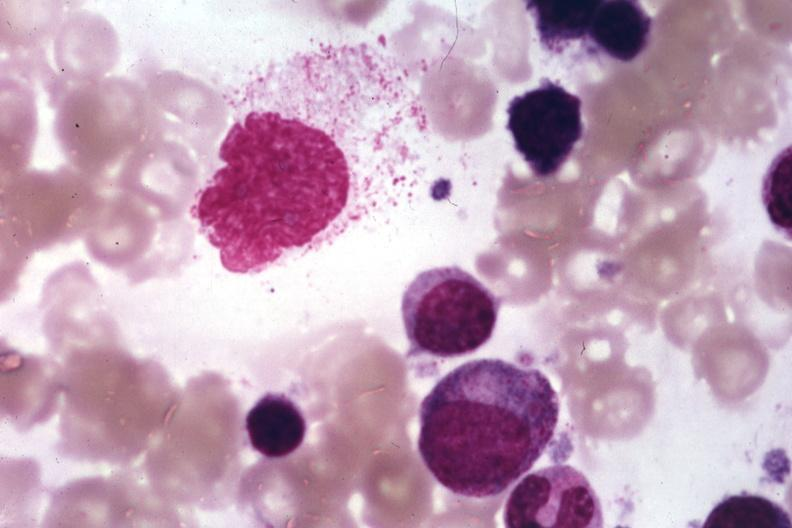what is present?
Answer the question using a single word or phrase. Hematologic 